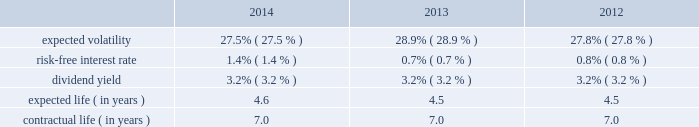Republic services , inc .
Notes to consolidated financial statements 2014 ( continued ) in december 2008 , the board of directors amended and restated the republic services , inc .
2006 incentive stock plan ( formerly known as the allied waste industries , inc .
2006 incentive stock plan ( the 2006 plan ) ) .
Allied 2019s shareholders approved the 2006 plan in may 2006 .
The 2006 plan was amended and restated in december 2008 to reflect republic as the new sponsor of the plan , and that any references to shares of common stock are to shares of common stock of republic , and to adjust outstanding awards and the number of shares available under the plan to reflect the allied acquisition .
The 2006 plan , as amended and restated , provided for the grant of non- qualified stock options , incentive stock options , shares of restricted stock , shares of phantom stock , stock bonuses , restricted stock units , stock appreciation rights , performance awards , dividend equivalents , cash awards , or other stock-based awards .
Awards granted under the 2006 plan prior to december 5 , 2008 became fully vested and nonforfeitable upon the closing of the allied acquisition .
No further awards will be made under the 2006 stock options we use a lattice binomial option-pricing model to value our stock option grants .
We recognize compensation expense on a straight-line basis over the requisite service period for each separately vesting portion of the award , or to the employee 2019s retirement eligible date , if earlier .
Expected volatility is based on the weighted average of the most recent one year volatility and a historical rolling average volatility of our stock over the expected life of the option .
The risk-free interest rate is based on federal reserve rates in effect for bonds with maturity dates equal to the expected term of the option .
We use historical data to estimate future option exercises , forfeitures ( at 3.0% ( 3.0 % ) for each of the periods presented ) and expected life of the options .
When appropriate , separate groups of employees that have similar historical exercise behavior are considered separately for valuation purposes .
The weighted-average estimated fair values of stock options granted during the years ended december 31 , 2014 , 2013 and 2012 were $ 5.74 , $ 5.27 and $ 4.77 per option , respectively , which were calculated using the following weighted-average assumptions: .

What was the percentage change in the expected volatility from 2012 to 2013? 
Rationale: the percentage change is the change from one period to the next divide by the earliest period
Computations: ((28.9 - 27.8) / 27.8)
Answer: 0.03957. Republic services , inc .
Notes to consolidated financial statements 2014 ( continued ) in december 2008 , the board of directors amended and restated the republic services , inc .
2006 incentive stock plan ( formerly known as the allied waste industries , inc .
2006 incentive stock plan ( the 2006 plan ) ) .
Allied 2019s shareholders approved the 2006 plan in may 2006 .
The 2006 plan was amended and restated in december 2008 to reflect republic as the new sponsor of the plan , and that any references to shares of common stock are to shares of common stock of republic , and to adjust outstanding awards and the number of shares available under the plan to reflect the allied acquisition .
The 2006 plan , as amended and restated , provided for the grant of non- qualified stock options , incentive stock options , shares of restricted stock , shares of phantom stock , stock bonuses , restricted stock units , stock appreciation rights , performance awards , dividend equivalents , cash awards , or other stock-based awards .
Awards granted under the 2006 plan prior to december 5 , 2008 became fully vested and nonforfeitable upon the closing of the allied acquisition .
No further awards will be made under the 2006 stock options we use a lattice binomial option-pricing model to value our stock option grants .
We recognize compensation expense on a straight-line basis over the requisite service period for each separately vesting portion of the award , or to the employee 2019s retirement eligible date , if earlier .
Expected volatility is based on the weighted average of the most recent one year volatility and a historical rolling average volatility of our stock over the expected life of the option .
The risk-free interest rate is based on federal reserve rates in effect for bonds with maturity dates equal to the expected term of the option .
We use historical data to estimate future option exercises , forfeitures ( at 3.0% ( 3.0 % ) for each of the periods presented ) and expected life of the options .
When appropriate , separate groups of employees that have similar historical exercise behavior are considered separately for valuation purposes .
The weighted-average estimated fair values of stock options granted during the years ended december 31 , 2014 , 2013 and 2012 were $ 5.74 , $ 5.27 and $ 4.77 per option , respectively , which were calculated using the following weighted-average assumptions: .

What was the percentage change in the weighted-average estimated fair values of stock options granted from 2013 to 2014? 
Rationale: the percentage change is the change from one period to the next divide by the earliest period
Computations: ((5.74 - 5.27) / 5.27)
Answer: 0.08918. 